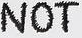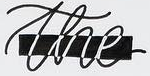What text is displayed in these images sequentially, separated by a semicolon? NOT; the 